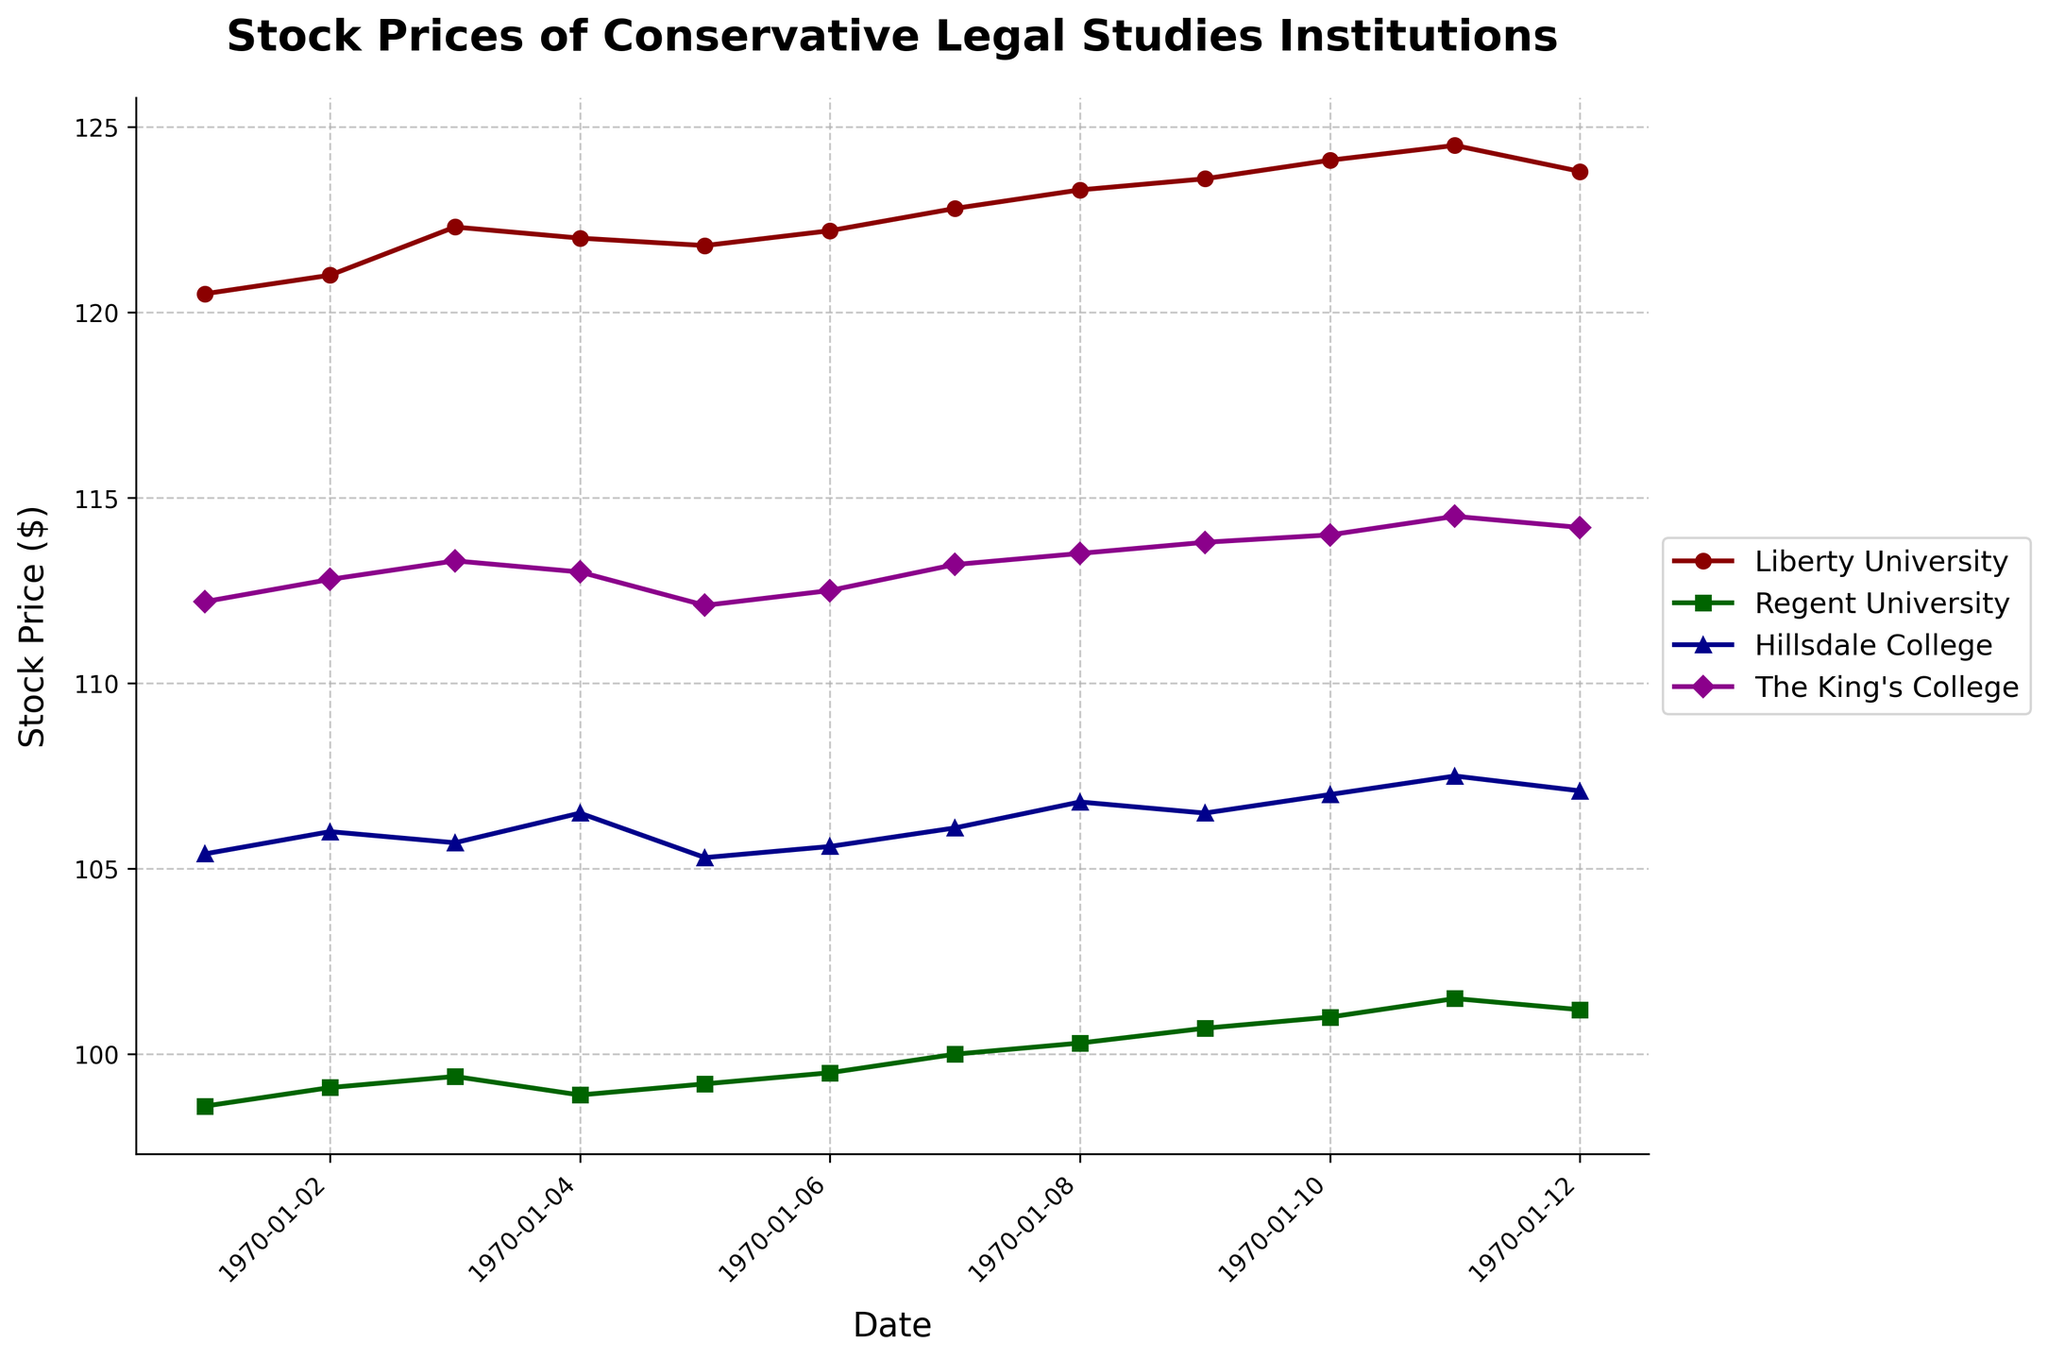What is the title of the plot? The title is displayed at the top of the plot in bold font. It reads "Stock Prices of Conservative Legal Studies Institutions".
Answer: Stock Prices of Conservative Legal Studies Institutions What are the x-axis and y-axis labels? The labels for the x-axis and y-axis are placed beside their respective axes. The x-axis label is "Date", and the y-axis label is "Stock Price ($)".
Answer: Date; Stock Price ($) How many educational institutions' stock prices are plotted in this figure? There are 4 different institutions, as indicated by the legend which lists Liberty University, Regent University, Hillsdale College, and The King's College.
Answer: 4 Which institution had the highest stock price on September 11, 2023? Examine the plot lines and their points on September 11, 2023. The highest stock price is marked by the line corresponding to Liberty University.
Answer: Liberty University What pattern do you observe in the stock prices of Regent University from September 1 to September 12, 2023? The stock prices for Regent University show a steady upward trend from 98.6 on September 1 to 101.2 on September 12, reflecting a consistent increase.
Answer: Consistent increase On what date did The King's College stock price exceed 113 for the first time? Follow the line for The King's College and identify the first point where it exceeds 113. This occurs on September 8, 2023.
Answer: September 8, 2023 Calculate the average stock price of Hillsdale College over the period shown. Add the stock prices for each date: 105.4 + 106.0 + 105.7 + 106.5 + 105.3 + 105.6 + 106.1 + 106.8 + 106.5 + 107.0 + 107.5 + 107.1 = 1227.5. Then divide by the number of days (12). The average is 1227.5/12 = 102.29
Answer: 102.29 Which institution's stock price showed the most volatility over the given period? Volatility can be determined by observing the fluctuations in stock prices. Liberty University shows the most movement, ranging from 120.5 to 124.5.
Answer: Liberty University Compare the stock prices of Liberty University and The King's College on September 12, 2023. Which one had a higher value and by how much? On September 12, Liberty University's stock price is 123.8, and The King's College's is 114.2. The difference is 123.8 - 114.2 = 9.6. Liberty University had a higher value by 9.6.
Answer: Liberty University by 9.6 What trend is observed in the stock prices of Liberty University from September 1 to September 12, 2023? The trend shows a general increase from 120.5 on September 1 to a peak of 124.5 on September 11, followed by a slight drop to 123.8 on September 12.
Answer: Increasing trend with a slight drop at the end 